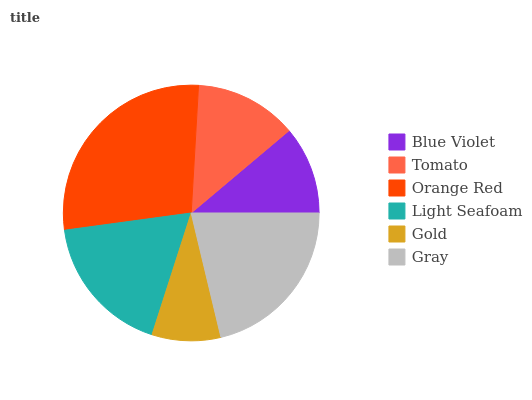Is Gold the minimum?
Answer yes or no. Yes. Is Orange Red the maximum?
Answer yes or no. Yes. Is Tomato the minimum?
Answer yes or no. No. Is Tomato the maximum?
Answer yes or no. No. Is Tomato greater than Blue Violet?
Answer yes or no. Yes. Is Blue Violet less than Tomato?
Answer yes or no. Yes. Is Blue Violet greater than Tomato?
Answer yes or no. No. Is Tomato less than Blue Violet?
Answer yes or no. No. Is Light Seafoam the high median?
Answer yes or no. Yes. Is Tomato the low median?
Answer yes or no. Yes. Is Orange Red the high median?
Answer yes or no. No. Is Gold the low median?
Answer yes or no. No. 